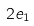Convert formula to latex. <formula><loc_0><loc_0><loc_500><loc_500>2 e _ { 1 }</formula> 